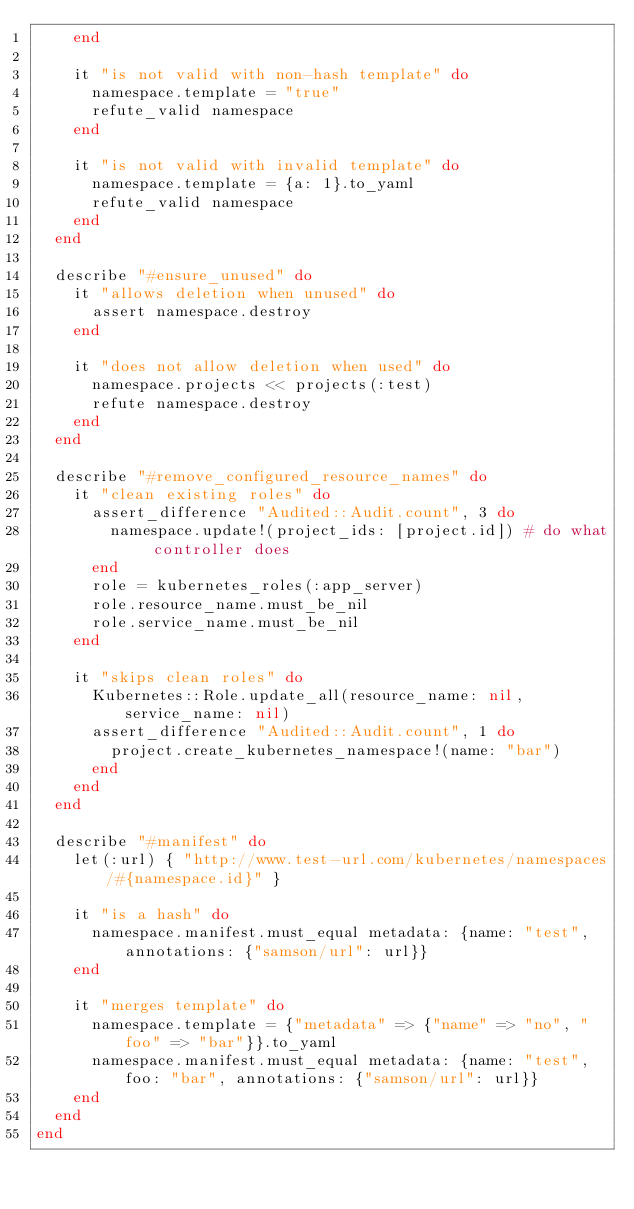Convert code to text. <code><loc_0><loc_0><loc_500><loc_500><_Ruby_>    end

    it "is not valid with non-hash template" do
      namespace.template = "true"
      refute_valid namespace
    end

    it "is not valid with invalid template" do
      namespace.template = {a: 1}.to_yaml
      refute_valid namespace
    end
  end

  describe "#ensure_unused" do
    it "allows deletion when unused" do
      assert namespace.destroy
    end

    it "does not allow deletion when used" do
      namespace.projects << projects(:test)
      refute namespace.destroy
    end
  end

  describe "#remove_configured_resource_names" do
    it "clean existing roles" do
      assert_difference "Audited::Audit.count", 3 do
        namespace.update!(project_ids: [project.id]) # do what controller does
      end
      role = kubernetes_roles(:app_server)
      role.resource_name.must_be_nil
      role.service_name.must_be_nil
    end

    it "skips clean roles" do
      Kubernetes::Role.update_all(resource_name: nil, service_name: nil)
      assert_difference "Audited::Audit.count", 1 do
        project.create_kubernetes_namespace!(name: "bar")
      end
    end
  end

  describe "#manifest" do
    let(:url) { "http://www.test-url.com/kubernetes/namespaces/#{namespace.id}" }

    it "is a hash" do
      namespace.manifest.must_equal metadata: {name: "test", annotations: {"samson/url": url}}
    end

    it "merges template" do
      namespace.template = {"metadata" => {"name" => "no", "foo" => "bar"}}.to_yaml
      namespace.manifest.must_equal metadata: {name: "test", foo: "bar", annotations: {"samson/url": url}}
    end
  end
end
</code> 